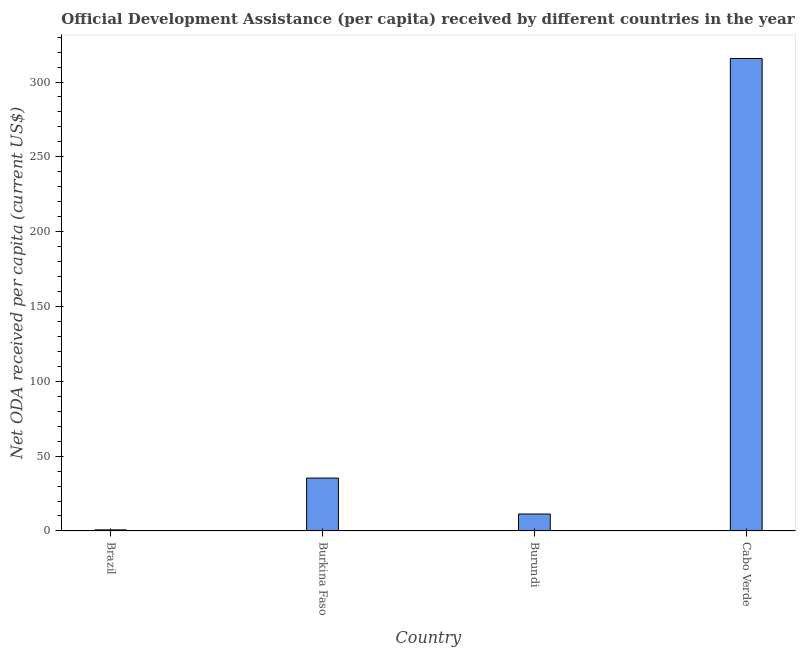What is the title of the graph?
Provide a short and direct response. Official Development Assistance (per capita) received by different countries in the year 1999. What is the label or title of the Y-axis?
Your answer should be very brief. Net ODA received per capita (current US$). What is the net oda received per capita in Burkina Faso?
Your answer should be compact. 35.33. Across all countries, what is the maximum net oda received per capita?
Keep it short and to the point. 315.71. Across all countries, what is the minimum net oda received per capita?
Your answer should be very brief. 0.71. In which country was the net oda received per capita maximum?
Provide a short and direct response. Cabo Verde. In which country was the net oda received per capita minimum?
Provide a succinct answer. Brazil. What is the sum of the net oda received per capita?
Make the answer very short. 363.06. What is the difference between the net oda received per capita in Brazil and Burkina Faso?
Your answer should be very brief. -34.62. What is the average net oda received per capita per country?
Give a very brief answer. 90.76. What is the median net oda received per capita?
Your answer should be compact. 23.32. In how many countries, is the net oda received per capita greater than 310 US$?
Keep it short and to the point. 1. What is the ratio of the net oda received per capita in Burundi to that in Cabo Verde?
Keep it short and to the point. 0.04. Is the net oda received per capita in Brazil less than that in Burundi?
Keep it short and to the point. Yes. Is the difference between the net oda received per capita in Brazil and Burundi greater than the difference between any two countries?
Offer a terse response. No. What is the difference between the highest and the second highest net oda received per capita?
Ensure brevity in your answer.  280.38. What is the difference between the highest and the lowest net oda received per capita?
Keep it short and to the point. 315. How many bars are there?
Offer a very short reply. 4. How many countries are there in the graph?
Your answer should be very brief. 4. What is the difference between two consecutive major ticks on the Y-axis?
Provide a succinct answer. 50. Are the values on the major ticks of Y-axis written in scientific E-notation?
Provide a short and direct response. No. What is the Net ODA received per capita (current US$) of Brazil?
Offer a terse response. 0.71. What is the Net ODA received per capita (current US$) in Burkina Faso?
Ensure brevity in your answer.  35.33. What is the Net ODA received per capita (current US$) in Burundi?
Your answer should be compact. 11.31. What is the Net ODA received per capita (current US$) in Cabo Verde?
Your answer should be very brief. 315.71. What is the difference between the Net ODA received per capita (current US$) in Brazil and Burkina Faso?
Provide a succinct answer. -34.62. What is the difference between the Net ODA received per capita (current US$) in Brazil and Burundi?
Your answer should be very brief. -10.6. What is the difference between the Net ODA received per capita (current US$) in Brazil and Cabo Verde?
Give a very brief answer. -315. What is the difference between the Net ODA received per capita (current US$) in Burkina Faso and Burundi?
Provide a short and direct response. 24.02. What is the difference between the Net ODA received per capita (current US$) in Burkina Faso and Cabo Verde?
Provide a short and direct response. -280.38. What is the difference between the Net ODA received per capita (current US$) in Burundi and Cabo Verde?
Your answer should be very brief. -304.4. What is the ratio of the Net ODA received per capita (current US$) in Brazil to that in Burundi?
Keep it short and to the point. 0.06. What is the ratio of the Net ODA received per capita (current US$) in Brazil to that in Cabo Verde?
Provide a short and direct response. 0. What is the ratio of the Net ODA received per capita (current US$) in Burkina Faso to that in Burundi?
Provide a short and direct response. 3.12. What is the ratio of the Net ODA received per capita (current US$) in Burkina Faso to that in Cabo Verde?
Give a very brief answer. 0.11. What is the ratio of the Net ODA received per capita (current US$) in Burundi to that in Cabo Verde?
Provide a succinct answer. 0.04. 